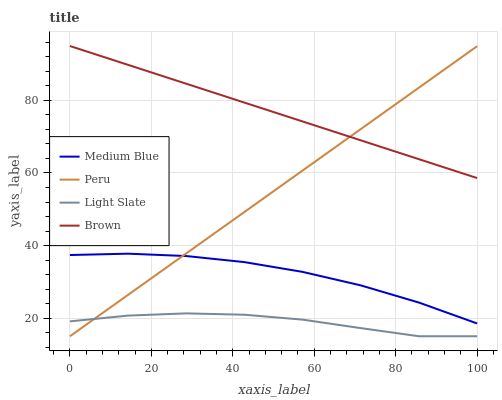Does Light Slate have the minimum area under the curve?
Answer yes or no. Yes. Does Brown have the maximum area under the curve?
Answer yes or no. Yes. Does Medium Blue have the minimum area under the curve?
Answer yes or no. No. Does Medium Blue have the maximum area under the curve?
Answer yes or no. No. Is Peru the smoothest?
Answer yes or no. Yes. Is Light Slate the roughest?
Answer yes or no. Yes. Is Brown the smoothest?
Answer yes or no. No. Is Brown the roughest?
Answer yes or no. No. Does Light Slate have the lowest value?
Answer yes or no. Yes. Does Medium Blue have the lowest value?
Answer yes or no. No. Does Brown have the highest value?
Answer yes or no. Yes. Does Medium Blue have the highest value?
Answer yes or no. No. Is Medium Blue less than Brown?
Answer yes or no. Yes. Is Brown greater than Light Slate?
Answer yes or no. Yes. Does Medium Blue intersect Peru?
Answer yes or no. Yes. Is Medium Blue less than Peru?
Answer yes or no. No. Is Medium Blue greater than Peru?
Answer yes or no. No. Does Medium Blue intersect Brown?
Answer yes or no. No. 